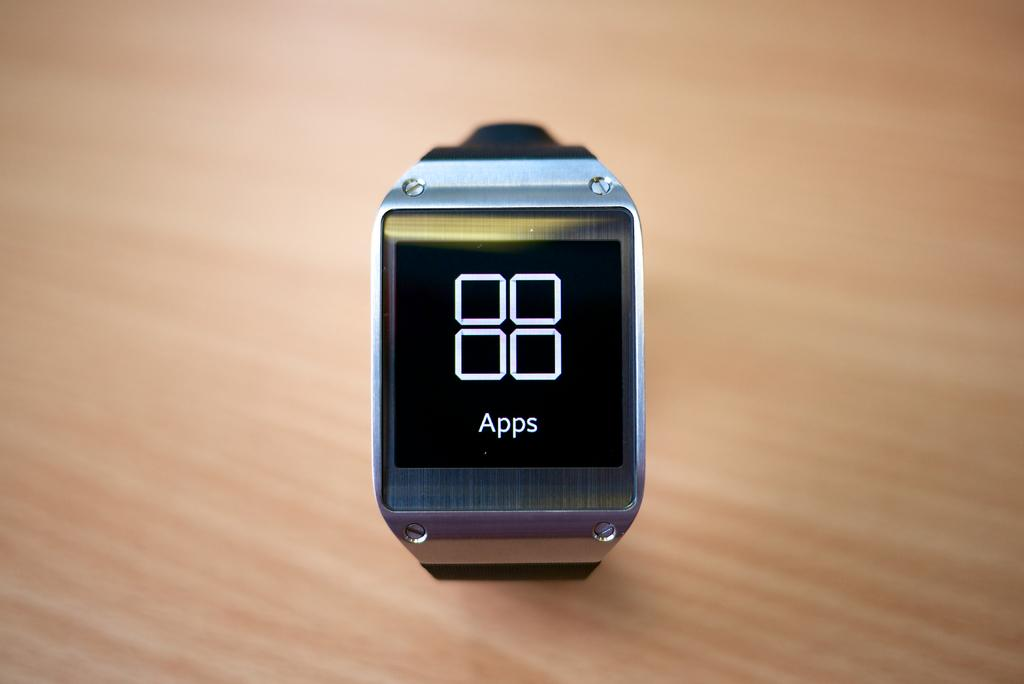<image>
Describe the image concisely. Smart watch that have apps on the front of it 